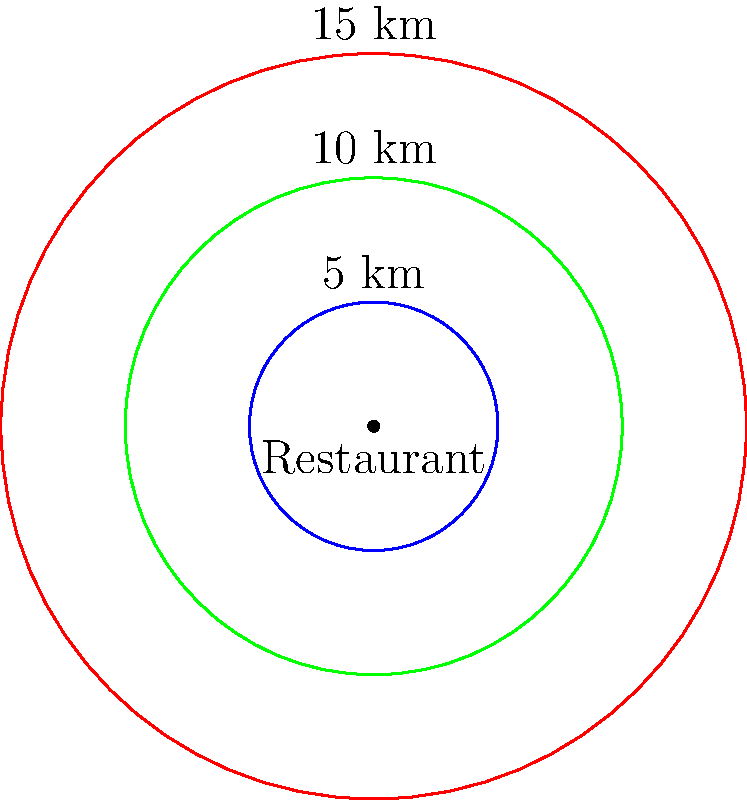The map shows three delivery radius options for your restaurant chain's new takeout service: 5 km (blue), 10 km (green), and 15 km (red). Given that profit margins decrease by 2% for every 5 km increase in delivery radius due to increased fuel and labor costs, but the number of potential customers increases by 40% with each 5 km expansion, which delivery radius would maximize profit? Let's analyze this step-by-step:

1) First, let's define our baseline:
   - 5 km radius: 100% profit margin, 100% customer base

2) For 10 km radius:
   - Profit margin: 100% - 2% = 98%
   - Customer base: 100% + 40% = 140%
   - Relative profit: $0.98 \times 1.40 = 1.372$ or 137.2%

3) For 15 km radius:
   - Profit margin: 98% - 2% = 96%
   - Customer base: 140% + 40% = 180%
   - Relative profit: $0.96 \times 1.80 = 1.728$ or 172.8%

4) Comparing the results:
   - 5 km: 100%
   - 10 km: 137.2%
   - 15 km: 172.8%

The 15 km radius provides the highest relative profit, despite the decreased profit margin, due to the significant increase in the customer base.
Answer: 15 km radius 